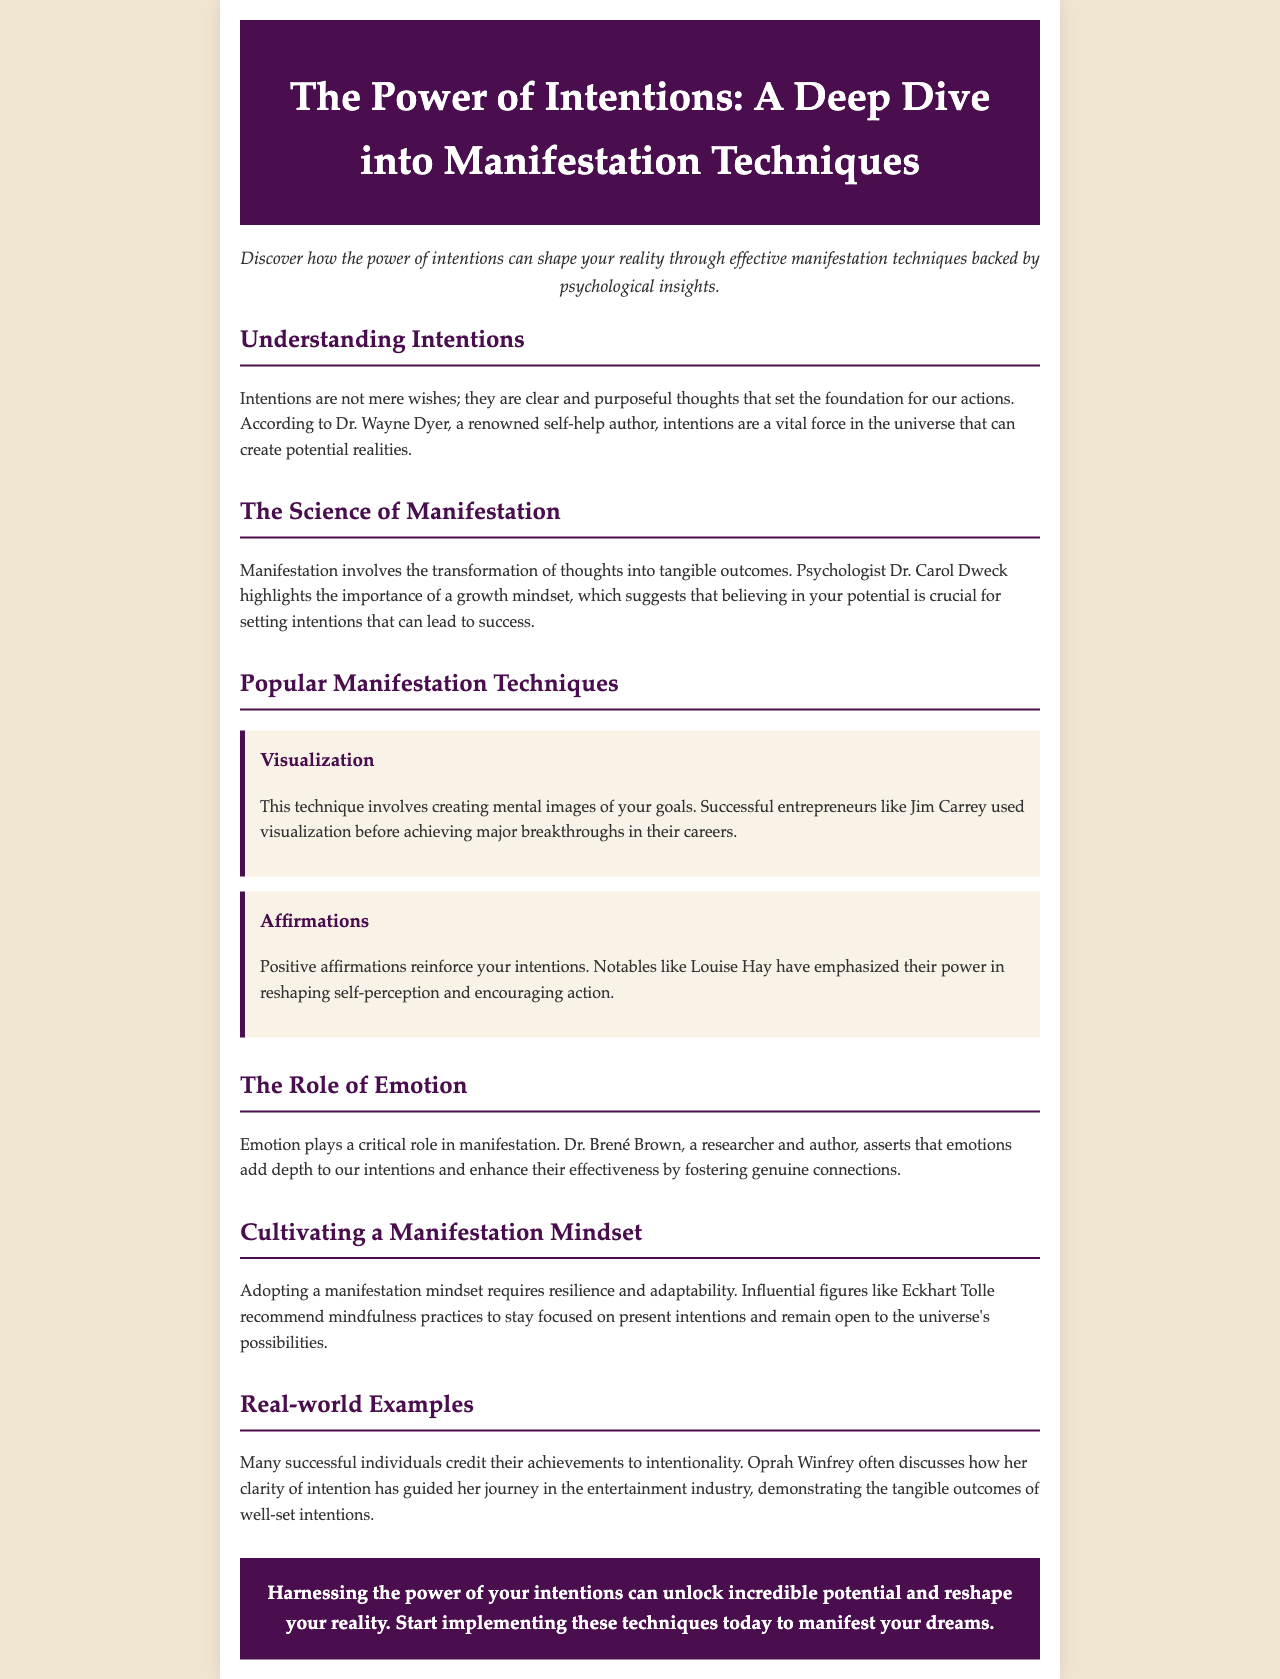What are intentions? Intentions are defined in the document as clear and purposeful thoughts that set the foundation for our actions.
Answer: Clear and purposeful thoughts Who emphasized the importance of a growth mindset? The document states that psychologist Dr. Carol Dweck highlights the importance of a growth mindset for setting intentions.
Answer: Dr. Carol Dweck What technique involves creating mental images of goals? The document mentions that visualization is the technique that involves this process.
Answer: Visualization Which notable figure is associated with positive affirmations? According to the newsletter, Louise Hay is emphasized for her work with positive affirmations.
Answer: Louise Hay What has Oprah Winfrey credited for guiding her journey? Oprah Winfrey often credits her clarity of intention as a guiding factor in her journey.
Answer: Clarity of intention What does Dr. Brené Brown assert about emotions? The document states that emotions add depth to intentions and enhance their effectiveness.
Answer: Add depth Who recommends mindfulness practices for a manifestation mindset? The document identifies Eckhart Tolle as an influential figure recommending these practices.
Answer: Eckhart Tolle What should one cultivate to manifest dreams? The conclusion suggests that one should cultivate the power of intentions to unlock potential.
Answer: Power of intentions What color is the header background? The header background color is specified as a dark shade: #4a0e4e.
Answer: #4a0e4e 